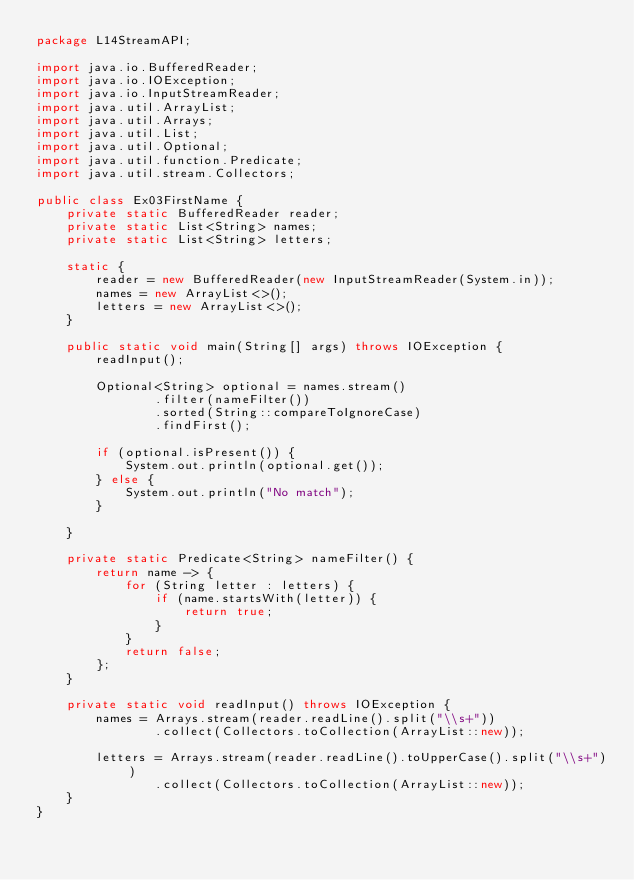Convert code to text. <code><loc_0><loc_0><loc_500><loc_500><_Java_>package L14StreamAPI;

import java.io.BufferedReader;
import java.io.IOException;
import java.io.InputStreamReader;
import java.util.ArrayList;
import java.util.Arrays;
import java.util.List;
import java.util.Optional;
import java.util.function.Predicate;
import java.util.stream.Collectors;

public class Ex03FirstName {
    private static BufferedReader reader;
    private static List<String> names;
    private static List<String> letters;

    static {
        reader = new BufferedReader(new InputStreamReader(System.in));
        names = new ArrayList<>();
        letters = new ArrayList<>();
    }

    public static void main(String[] args) throws IOException {
        readInput();

        Optional<String> optional = names.stream()
                .filter(nameFilter())
                .sorted(String::compareToIgnoreCase)
                .findFirst();

        if (optional.isPresent()) {
            System.out.println(optional.get());
        } else {
            System.out.println("No match");
        }

    }

    private static Predicate<String> nameFilter() {
        return name -> {
            for (String letter : letters) {
                if (name.startsWith(letter)) {
                    return true;
                }
            }
            return false;
        };
    }

    private static void readInput() throws IOException {
        names = Arrays.stream(reader.readLine().split("\\s+"))
                .collect(Collectors.toCollection(ArrayList::new));

        letters = Arrays.stream(reader.readLine().toUpperCase().split("\\s+"))
                .collect(Collectors.toCollection(ArrayList::new));
    }
}
</code> 